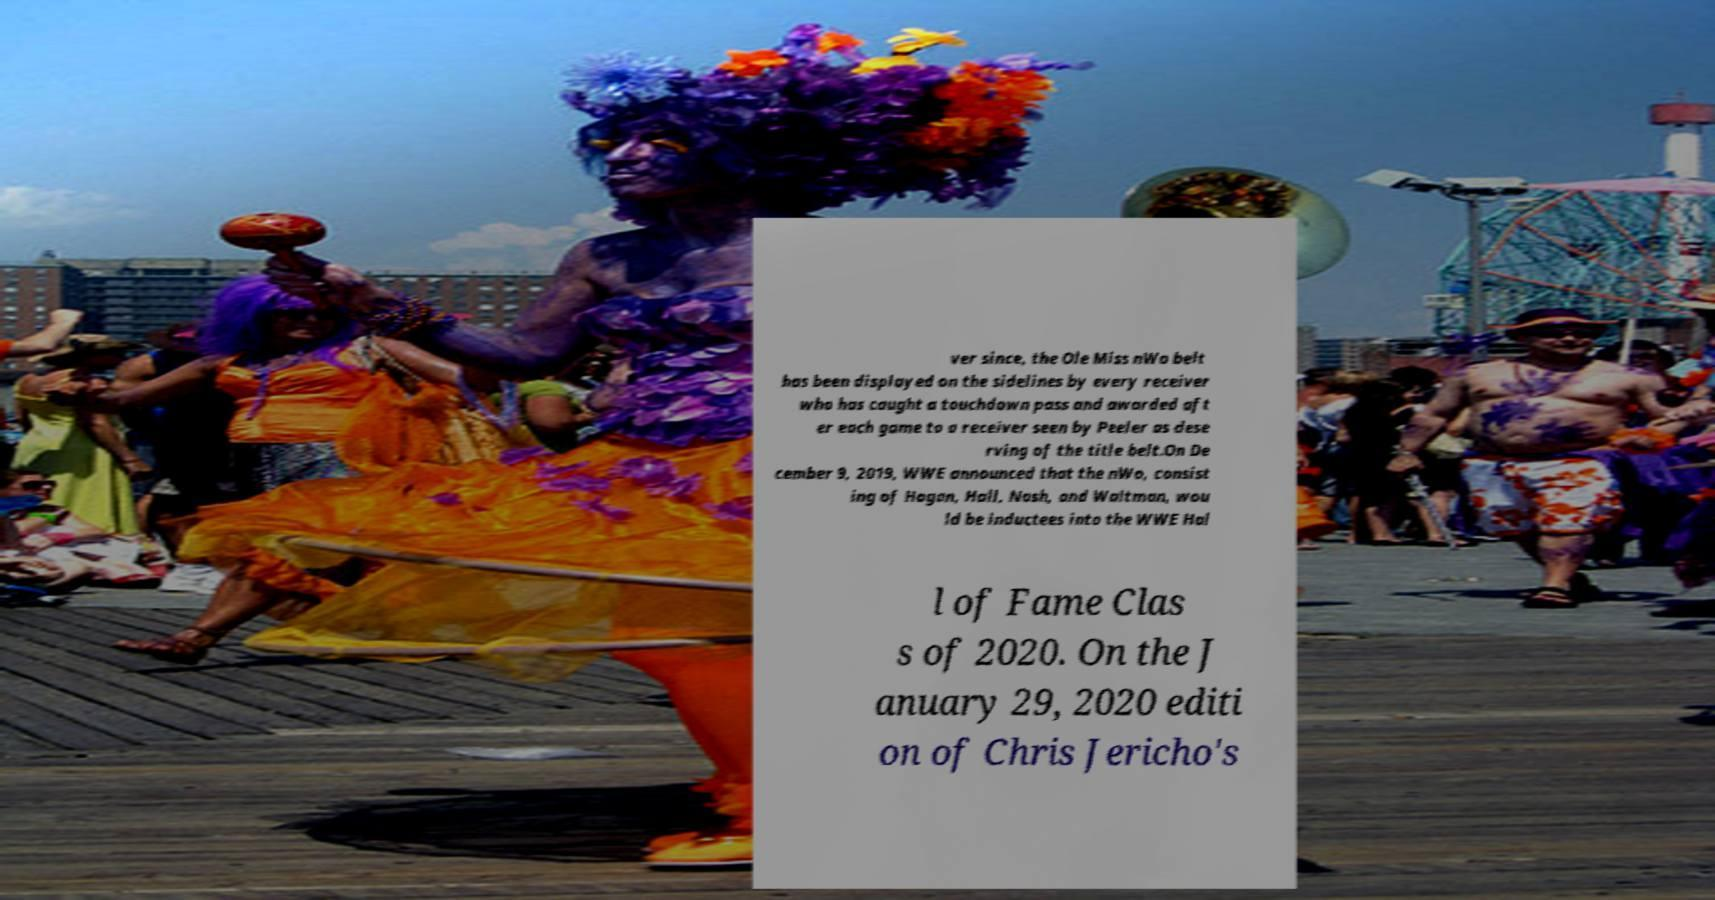There's text embedded in this image that I need extracted. Can you transcribe it verbatim? ver since, the Ole Miss nWo belt has been displayed on the sidelines by every receiver who has caught a touchdown pass and awarded aft er each game to a receiver seen by Peeler as dese rving of the title belt.On De cember 9, 2019, WWE announced that the nWo, consist ing of Hogan, Hall, Nash, and Waltman, wou ld be inductees into the WWE Hal l of Fame Clas s of 2020. On the J anuary 29, 2020 editi on of Chris Jericho's 